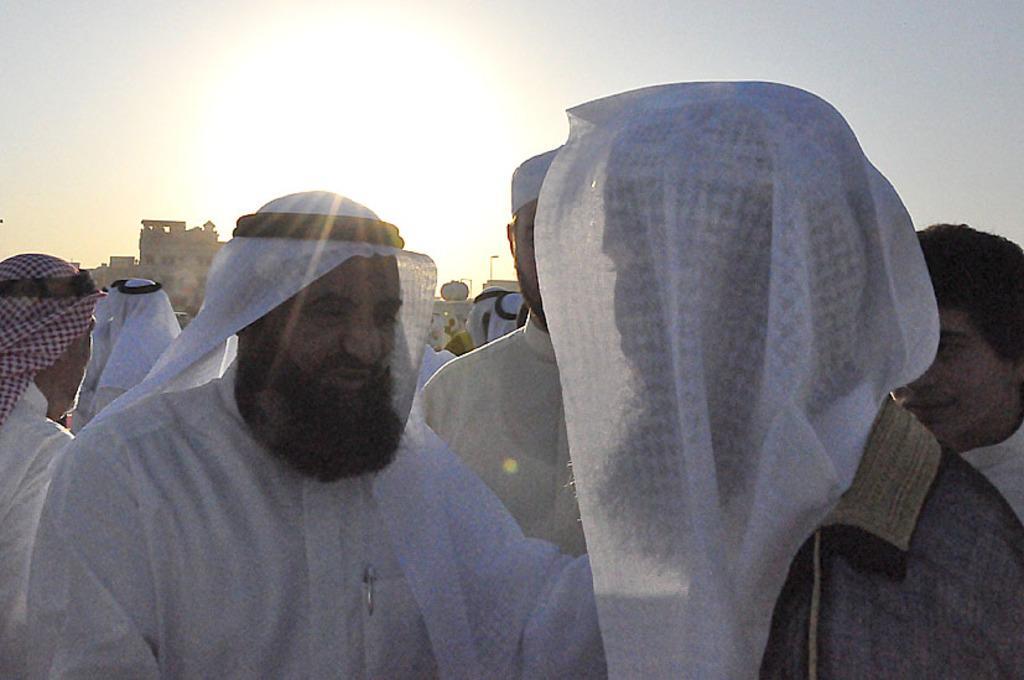Can you describe this image briefly? In this picture we can see a group of people and in the background we can see buildings and the sky. 